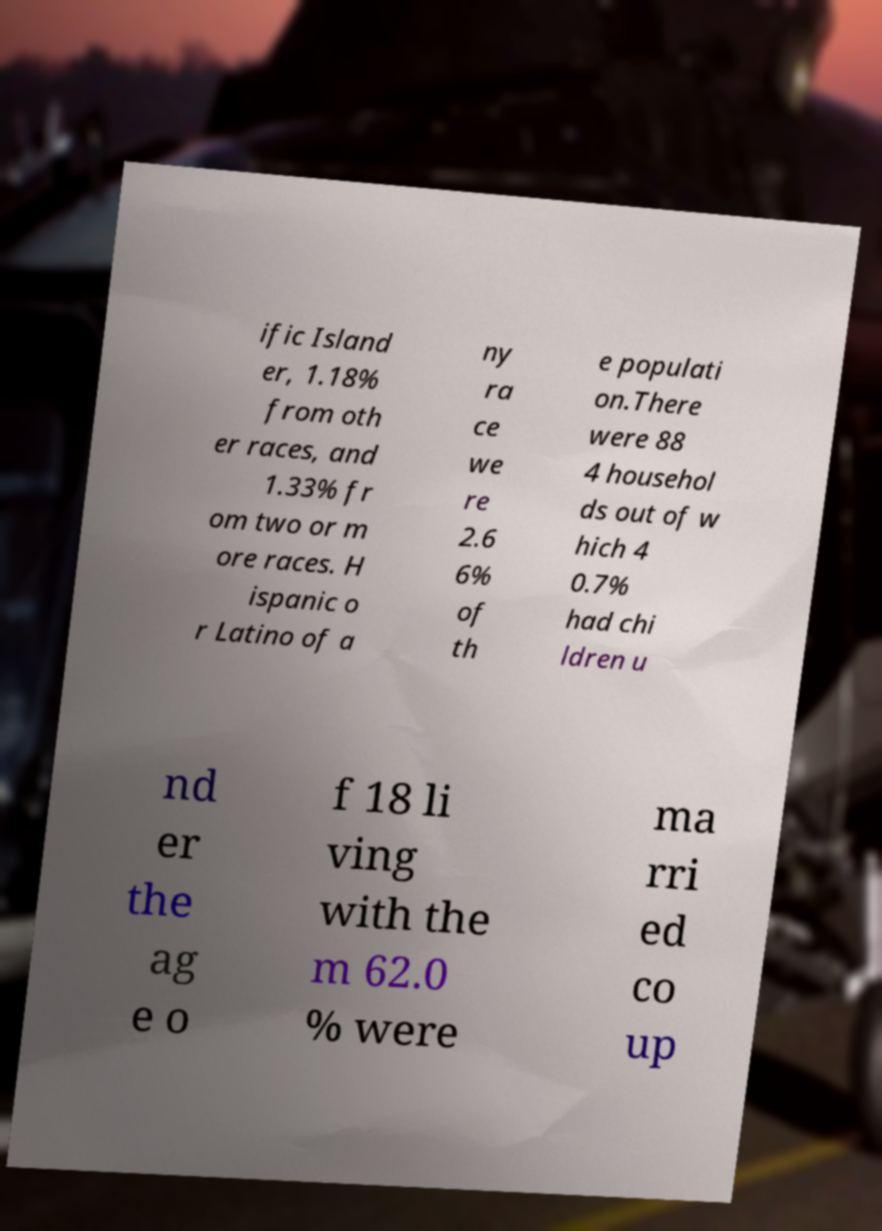Could you assist in decoding the text presented in this image and type it out clearly? ific Island er, 1.18% from oth er races, and 1.33% fr om two or m ore races. H ispanic o r Latino of a ny ra ce we re 2.6 6% of th e populati on.There were 88 4 househol ds out of w hich 4 0.7% had chi ldren u nd er the ag e o f 18 li ving with the m 62.0 % were ma rri ed co up 